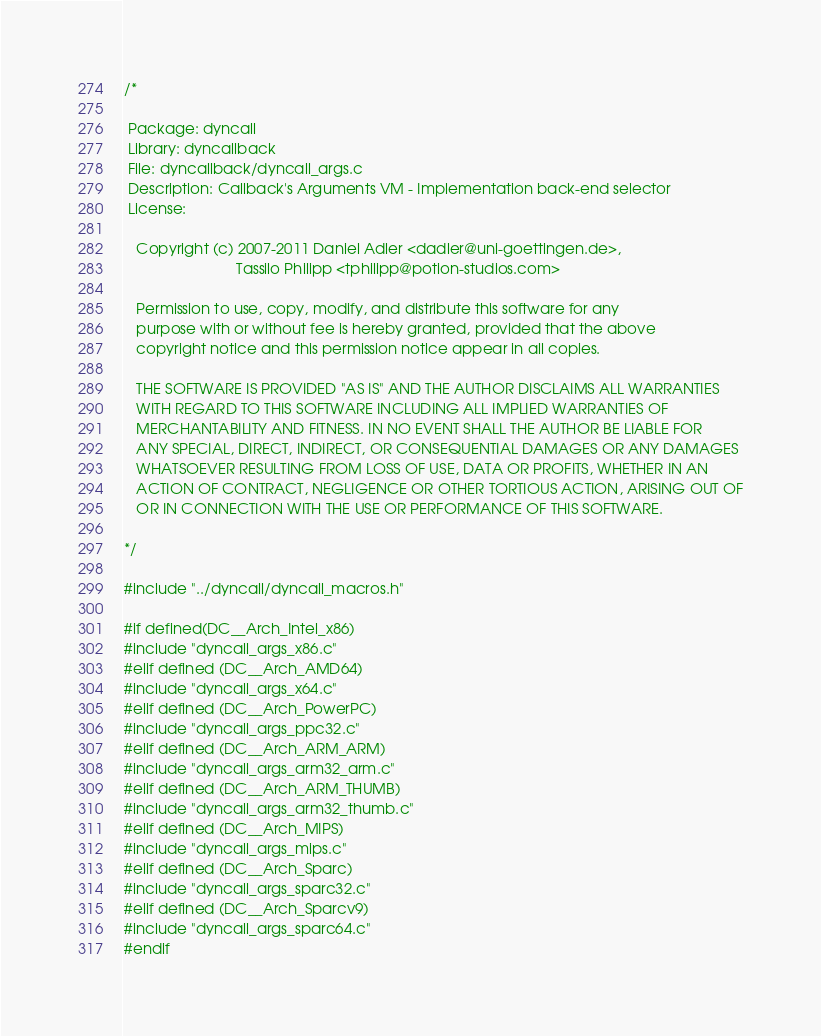<code> <loc_0><loc_0><loc_500><loc_500><_C_>/*

 Package: dyncall
 Library: dyncallback
 File: dyncallback/dyncall_args.c
 Description: Callback's Arguments VM - Implementation back-end selector
 License:

   Copyright (c) 2007-2011 Daniel Adler <dadler@uni-goettingen.de>,
                           Tassilo Philipp <tphilipp@potion-studios.com>

   Permission to use, copy, modify, and distribute this software for any
   purpose with or without fee is hereby granted, provided that the above
   copyright notice and this permission notice appear in all copies.

   THE SOFTWARE IS PROVIDED "AS IS" AND THE AUTHOR DISCLAIMS ALL WARRANTIES
   WITH REGARD TO THIS SOFTWARE INCLUDING ALL IMPLIED WARRANTIES OF
   MERCHANTABILITY AND FITNESS. IN NO EVENT SHALL THE AUTHOR BE LIABLE FOR
   ANY SPECIAL, DIRECT, INDIRECT, OR CONSEQUENTIAL DAMAGES OR ANY DAMAGES
   WHATSOEVER RESULTING FROM LOSS OF USE, DATA OR PROFITS, WHETHER IN AN
   ACTION OF CONTRACT, NEGLIGENCE OR OTHER TORTIOUS ACTION, ARISING OUT OF
   OR IN CONNECTION WITH THE USE OR PERFORMANCE OF THIS SOFTWARE.

*/

#include "../dyncall/dyncall_macros.h"

#if defined(DC__Arch_Intel_x86)
#include "dyncall_args_x86.c"
#elif defined (DC__Arch_AMD64)
#include "dyncall_args_x64.c"
#elif defined (DC__Arch_PowerPC)
#include "dyncall_args_ppc32.c"
#elif defined (DC__Arch_ARM_ARM)
#include "dyncall_args_arm32_arm.c"
#elif defined (DC__Arch_ARM_THUMB)
#include "dyncall_args_arm32_thumb.c"
#elif defined (DC__Arch_MIPS)
#include "dyncall_args_mips.c"
#elif defined (DC__Arch_Sparc)
#include "dyncall_args_sparc32.c"
#elif defined (DC__Arch_Sparcv9)
#include "dyncall_args_sparc64.c"
#endif

</code> 